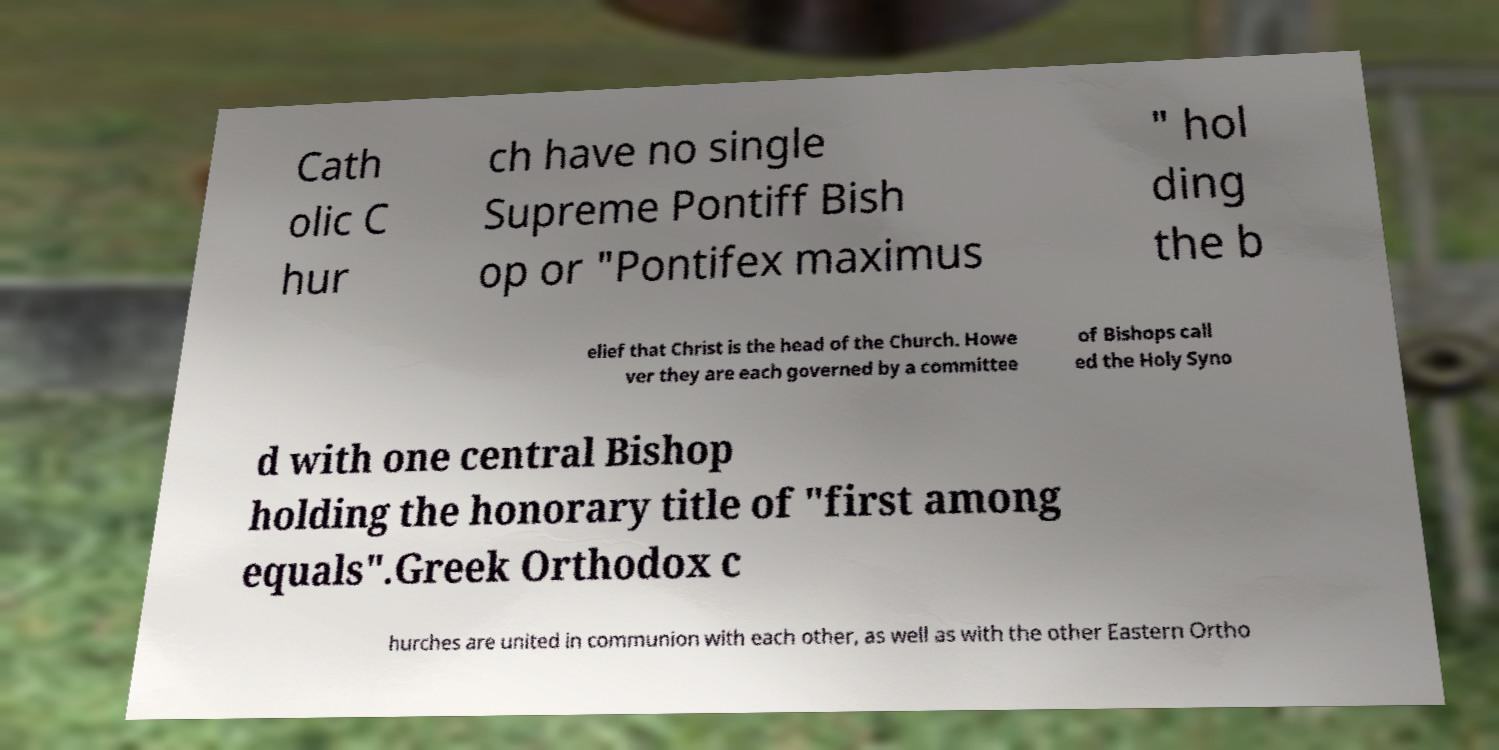Could you extract and type out the text from this image? Cath olic C hur ch have no single Supreme Pontiff Bish op or "Pontifex maximus " hol ding the b elief that Christ is the head of the Church. Howe ver they are each governed by a committee of Bishops call ed the Holy Syno d with one central Bishop holding the honorary title of "first among equals".Greek Orthodox c hurches are united in communion with each other, as well as with the other Eastern Ortho 